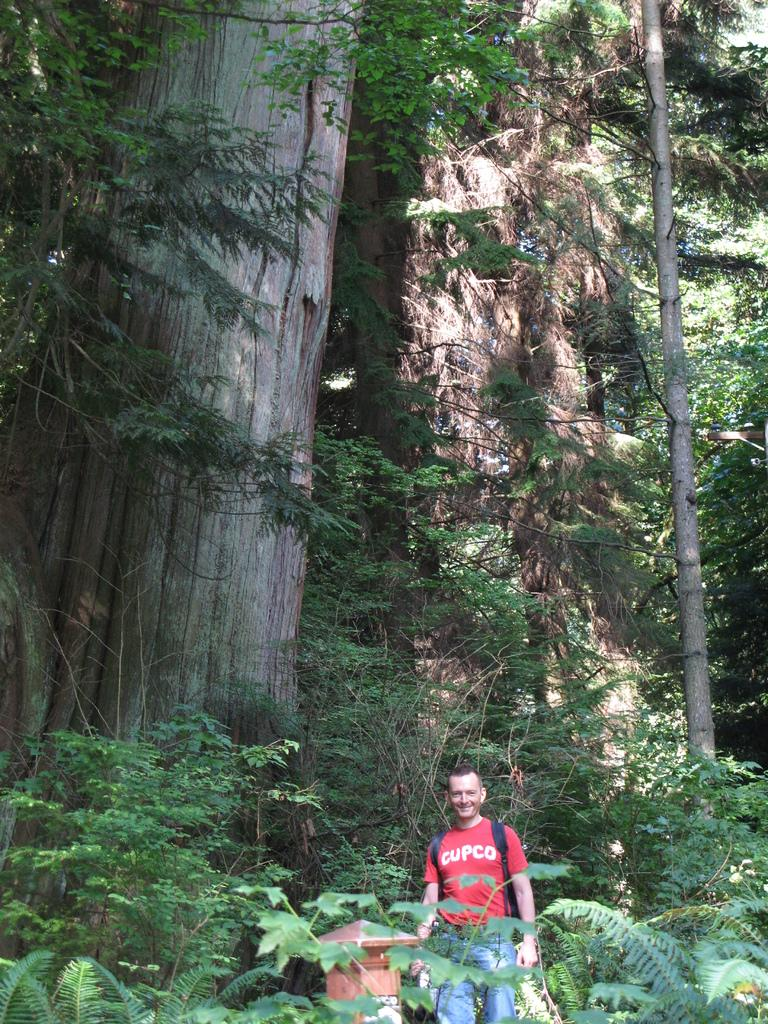What is the main subject of the image? There is a man in the image. What is the man doing in the image? The man is standing in the image. What is the man's facial expression in the image? The man is smiling in the image. What colors are the man's clothes in the image? The man is wearing a red color t-shirt and blue color jeans in the image. What can be seen in the background of the image? There are trees and plants in the background of the image. What type of offer is the man making in the image? There is no offer being made in the image; the man is simply standing and smiling. 